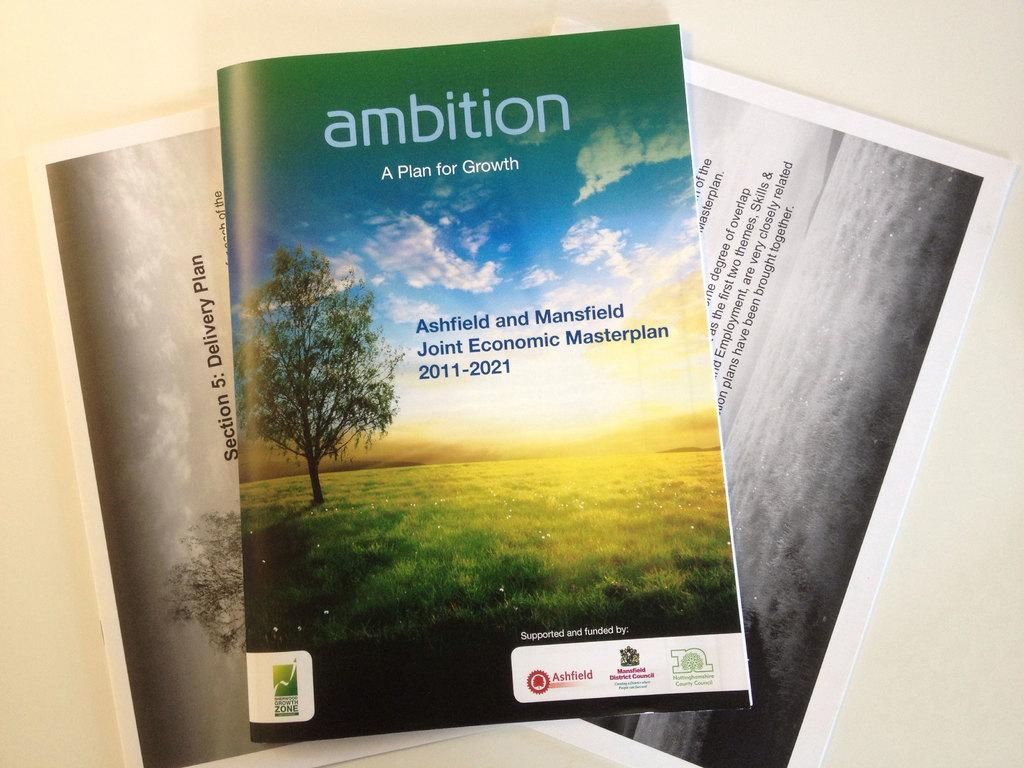Provide a one-sentence caption for the provided image. Magazine book with a title of "Ambition" on the top. 